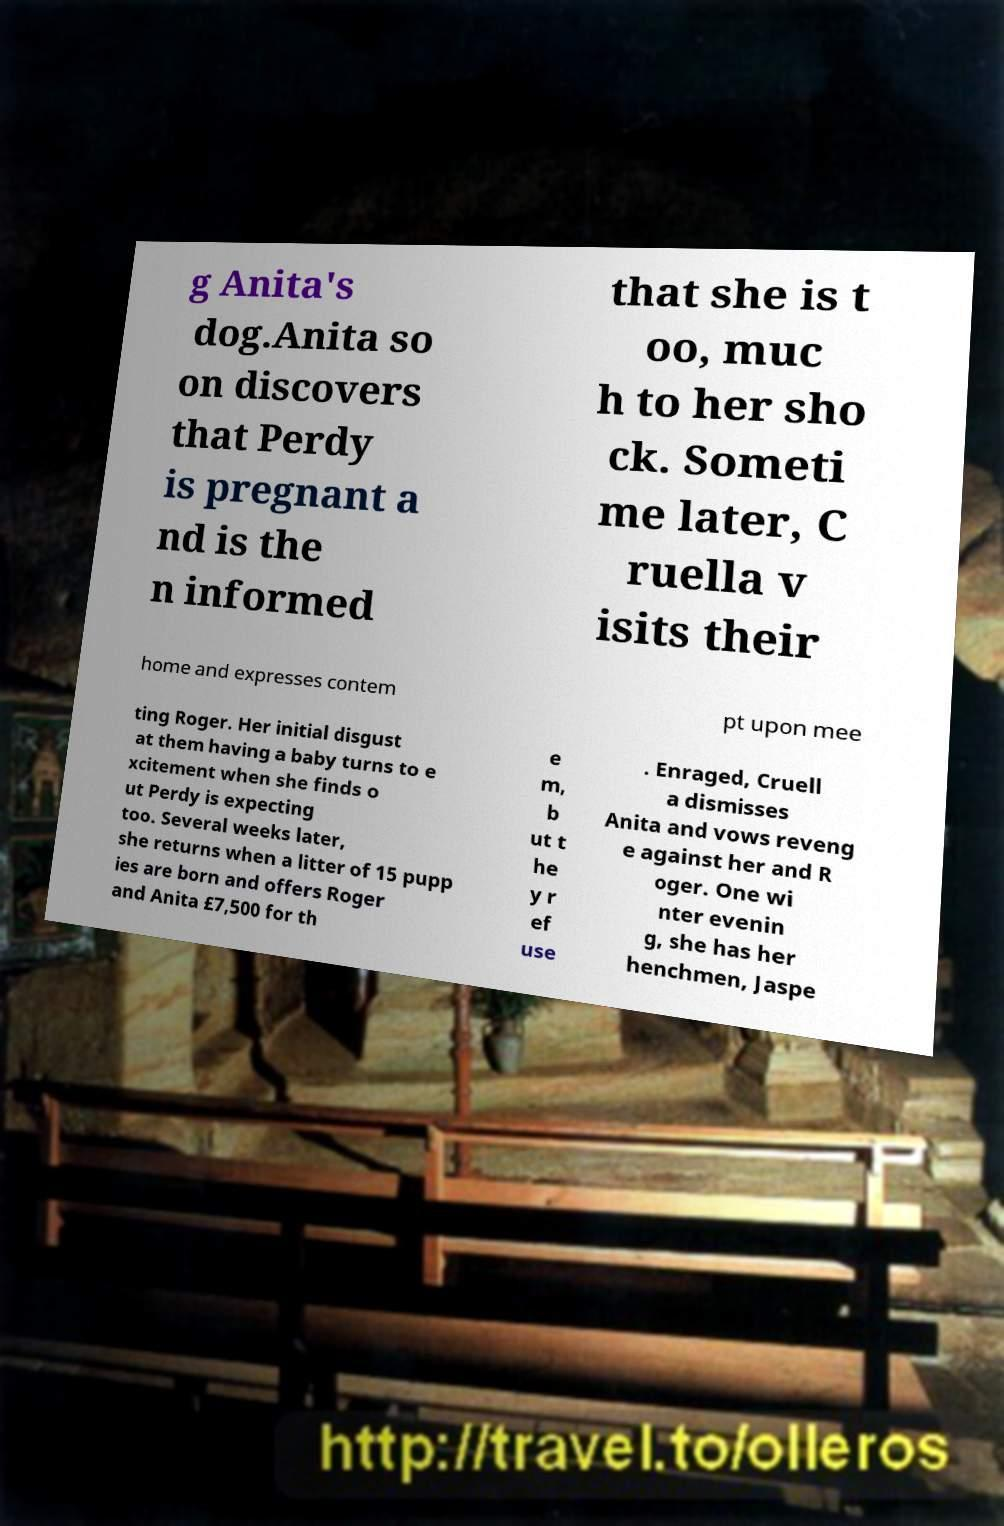Can you accurately transcribe the text from the provided image for me? g Anita's dog.Anita so on discovers that Perdy is pregnant a nd is the n informed that she is t oo, muc h to her sho ck. Someti me later, C ruella v isits their home and expresses contem pt upon mee ting Roger. Her initial disgust at them having a baby turns to e xcitement when she finds o ut Perdy is expecting too. Several weeks later, she returns when a litter of 15 pupp ies are born and offers Roger and Anita £7,500 for th e m, b ut t he y r ef use . Enraged, Cruell a dismisses Anita and vows reveng e against her and R oger. One wi nter evenin g, she has her henchmen, Jaspe 